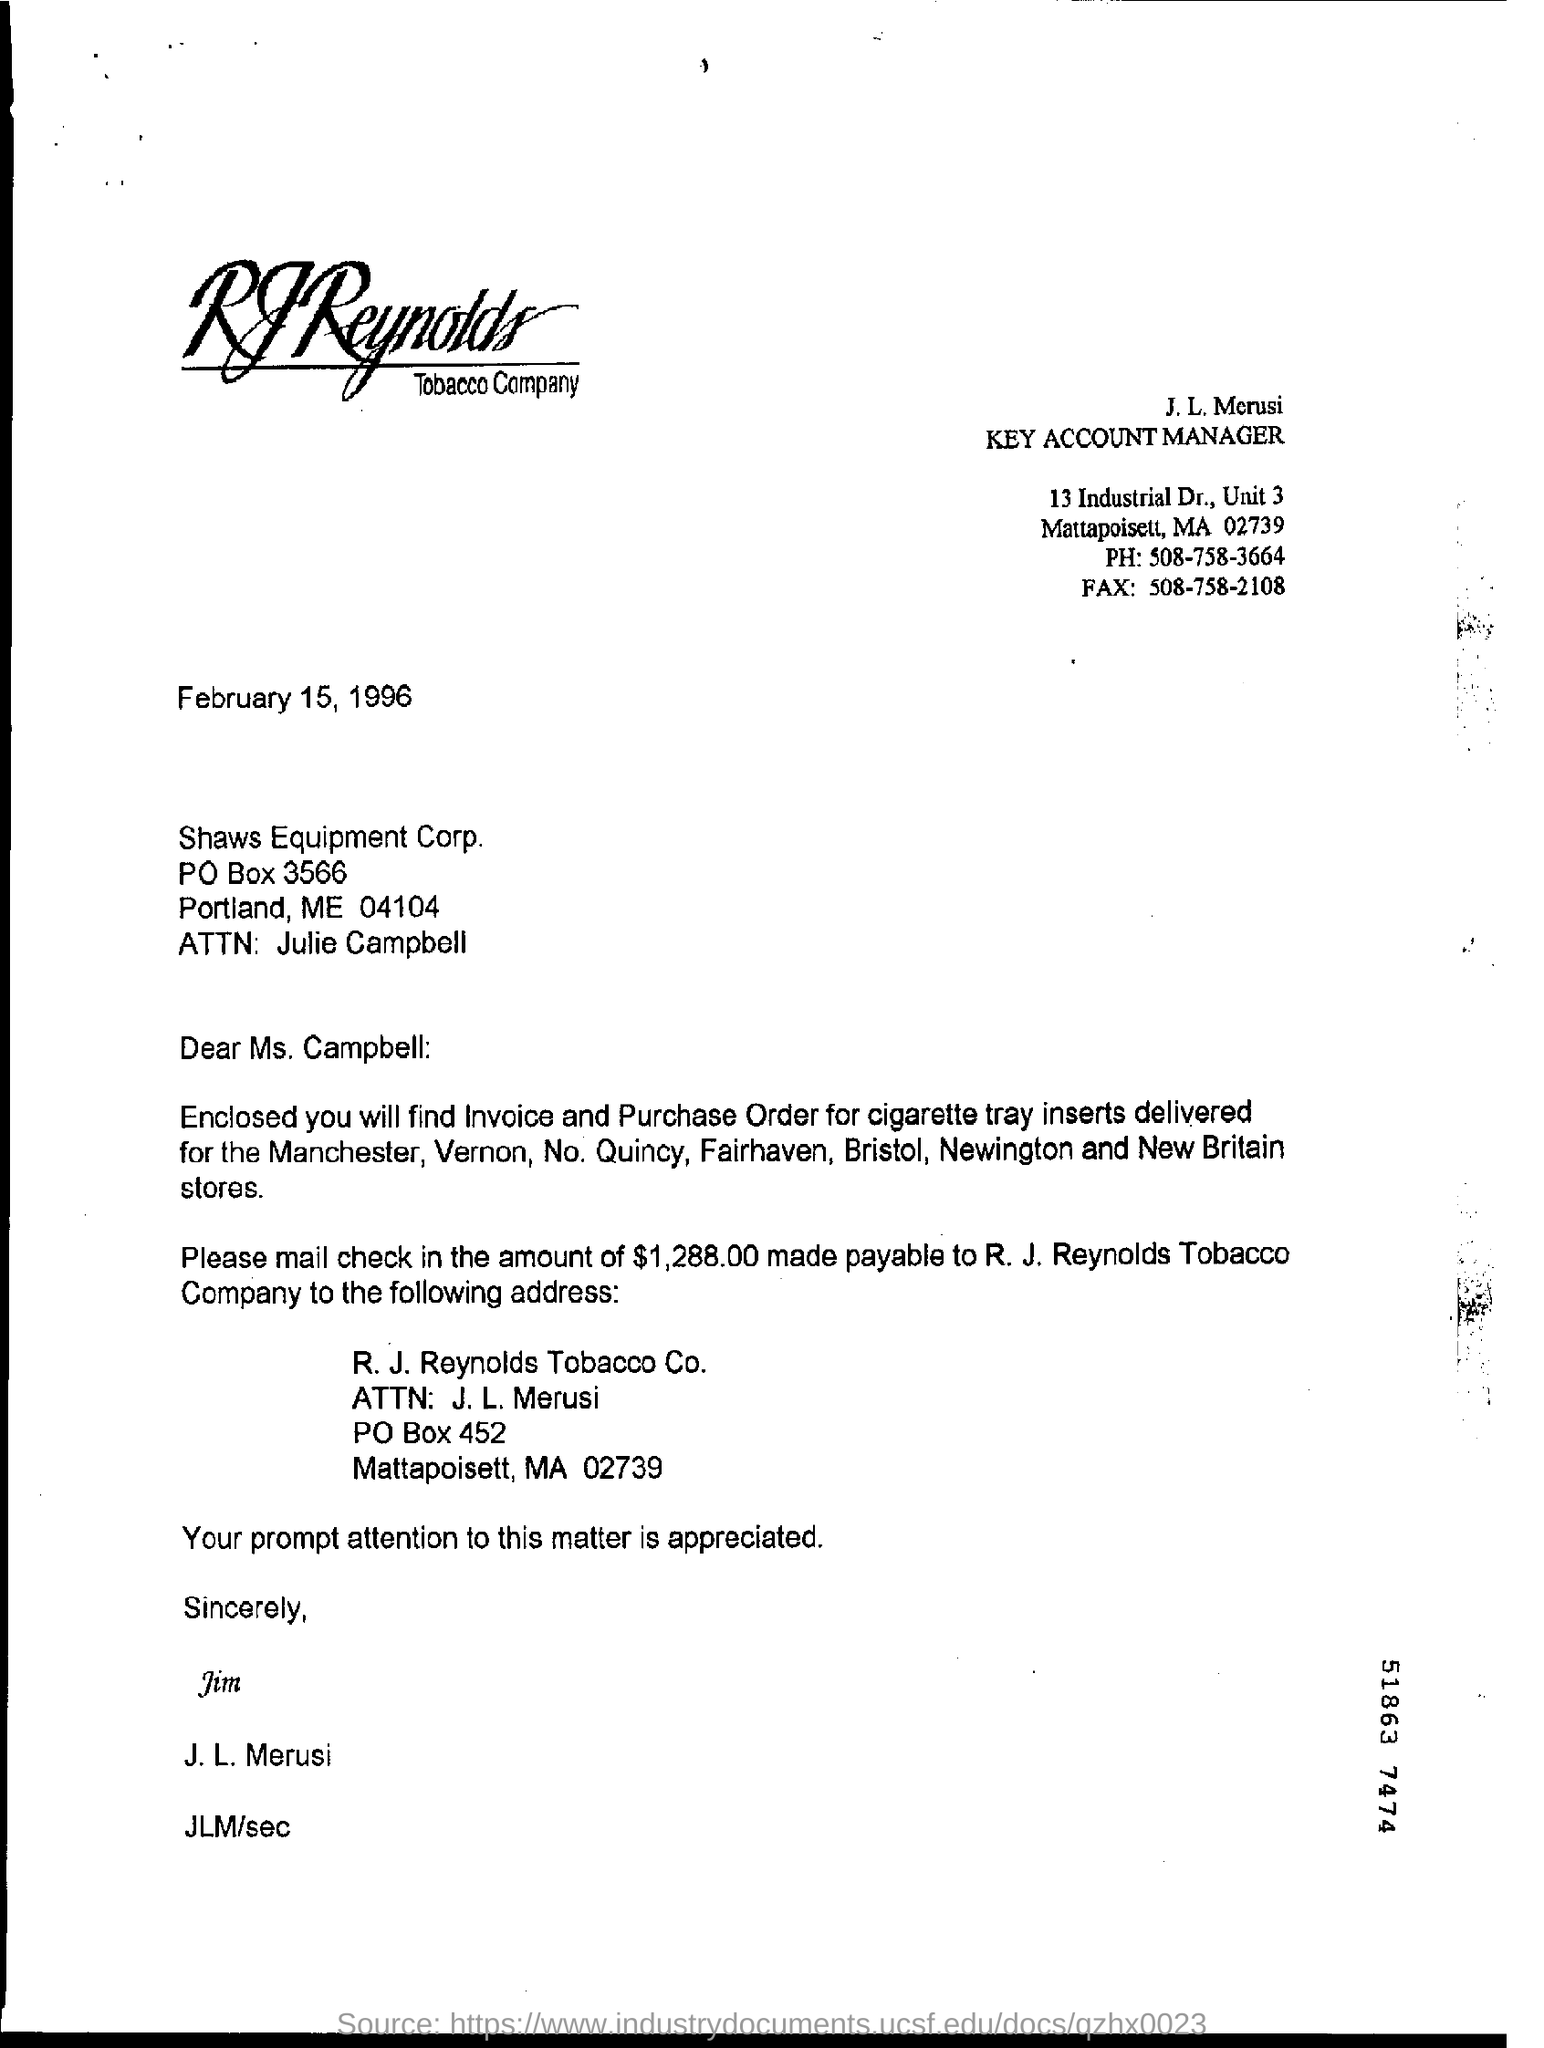Specify some key components in this picture. The fax number mentioned in the letter is 508-758-2108. 